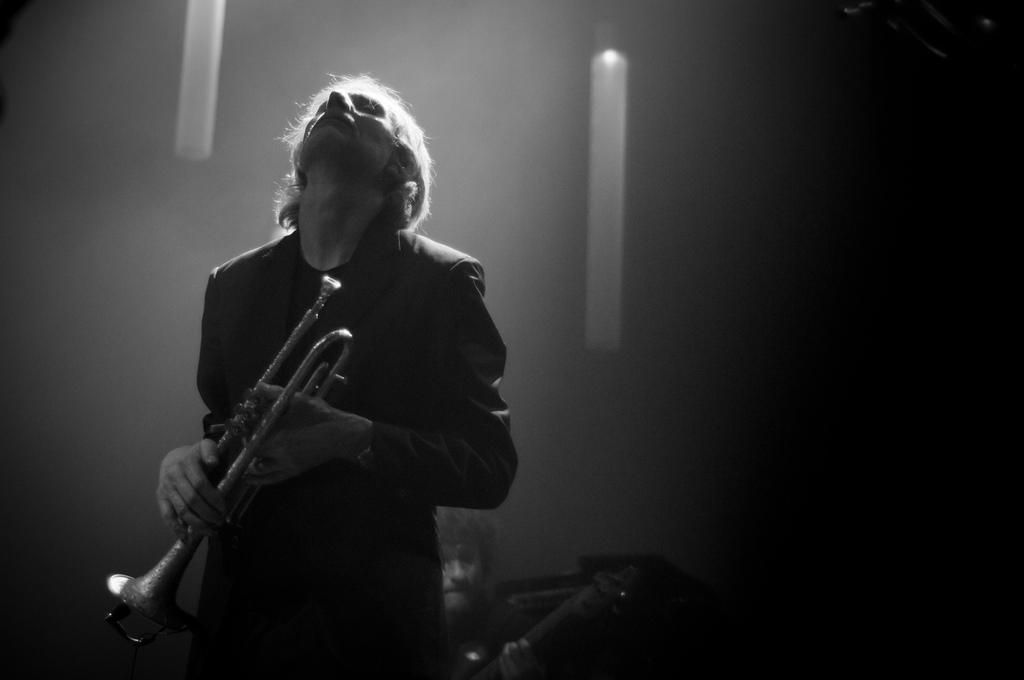Could you give a brief overview of what you see in this image? In front of the image there is a person holding the saxophone. Behind him there is a person holding some object. Behind him there is some object. There are a few objects hanging from the top. 